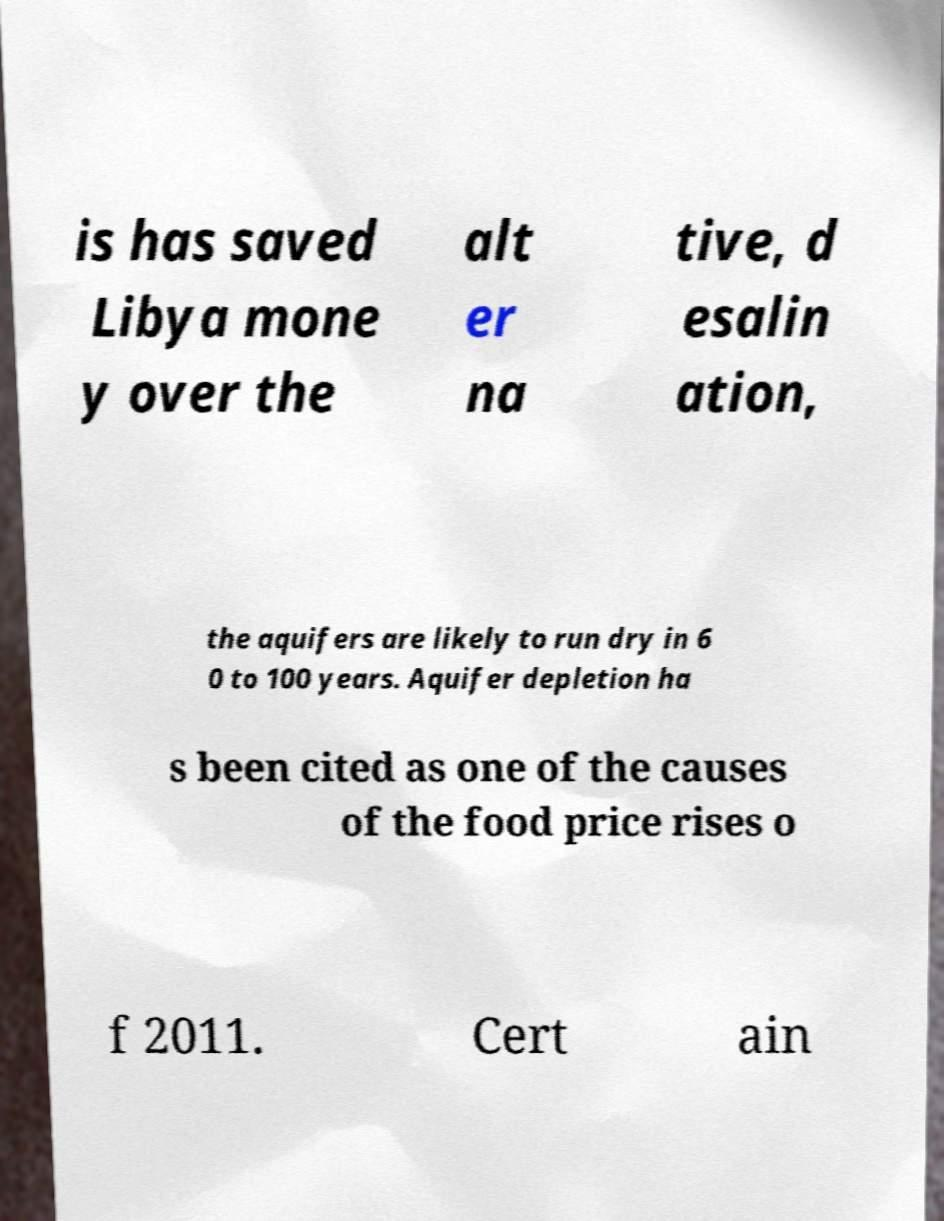Can you read and provide the text displayed in the image?This photo seems to have some interesting text. Can you extract and type it out for me? is has saved Libya mone y over the alt er na tive, d esalin ation, the aquifers are likely to run dry in 6 0 to 100 years. Aquifer depletion ha s been cited as one of the causes of the food price rises o f 2011. Cert ain 